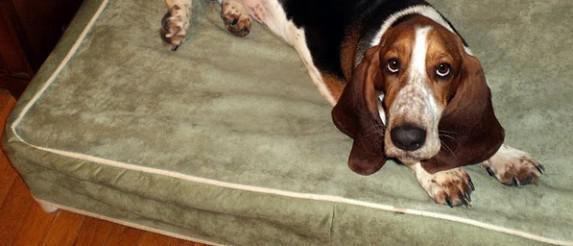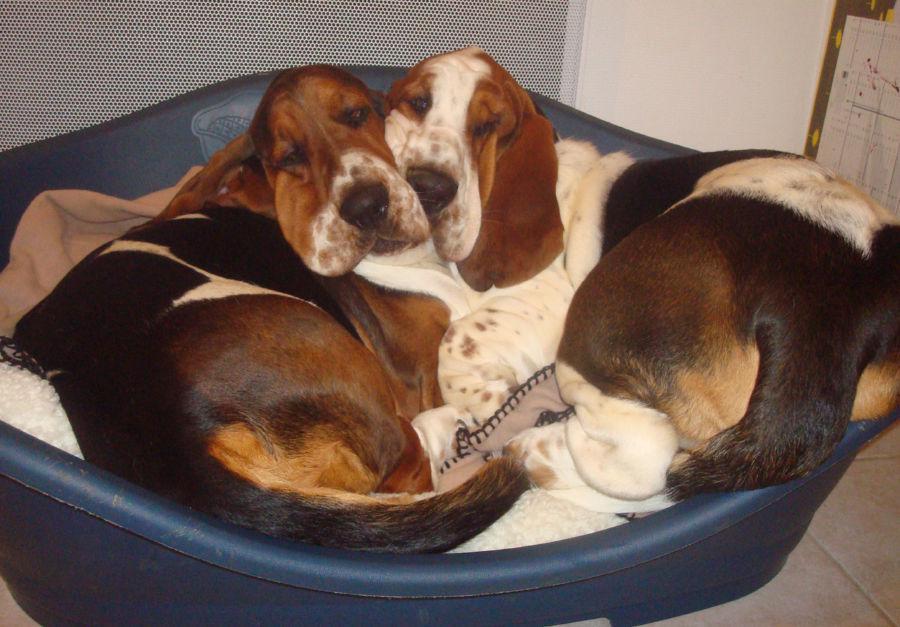The first image is the image on the left, the second image is the image on the right. Evaluate the accuracy of this statement regarding the images: "Two basset hounds snuggle together in a round pet bed, in one image.". Is it true? Answer yes or no. Yes. The first image is the image on the left, the second image is the image on the right. For the images displayed, is the sentence "One image shows two adult basset hounds sleeping in a round dog bed together" factually correct? Answer yes or no. Yes. 